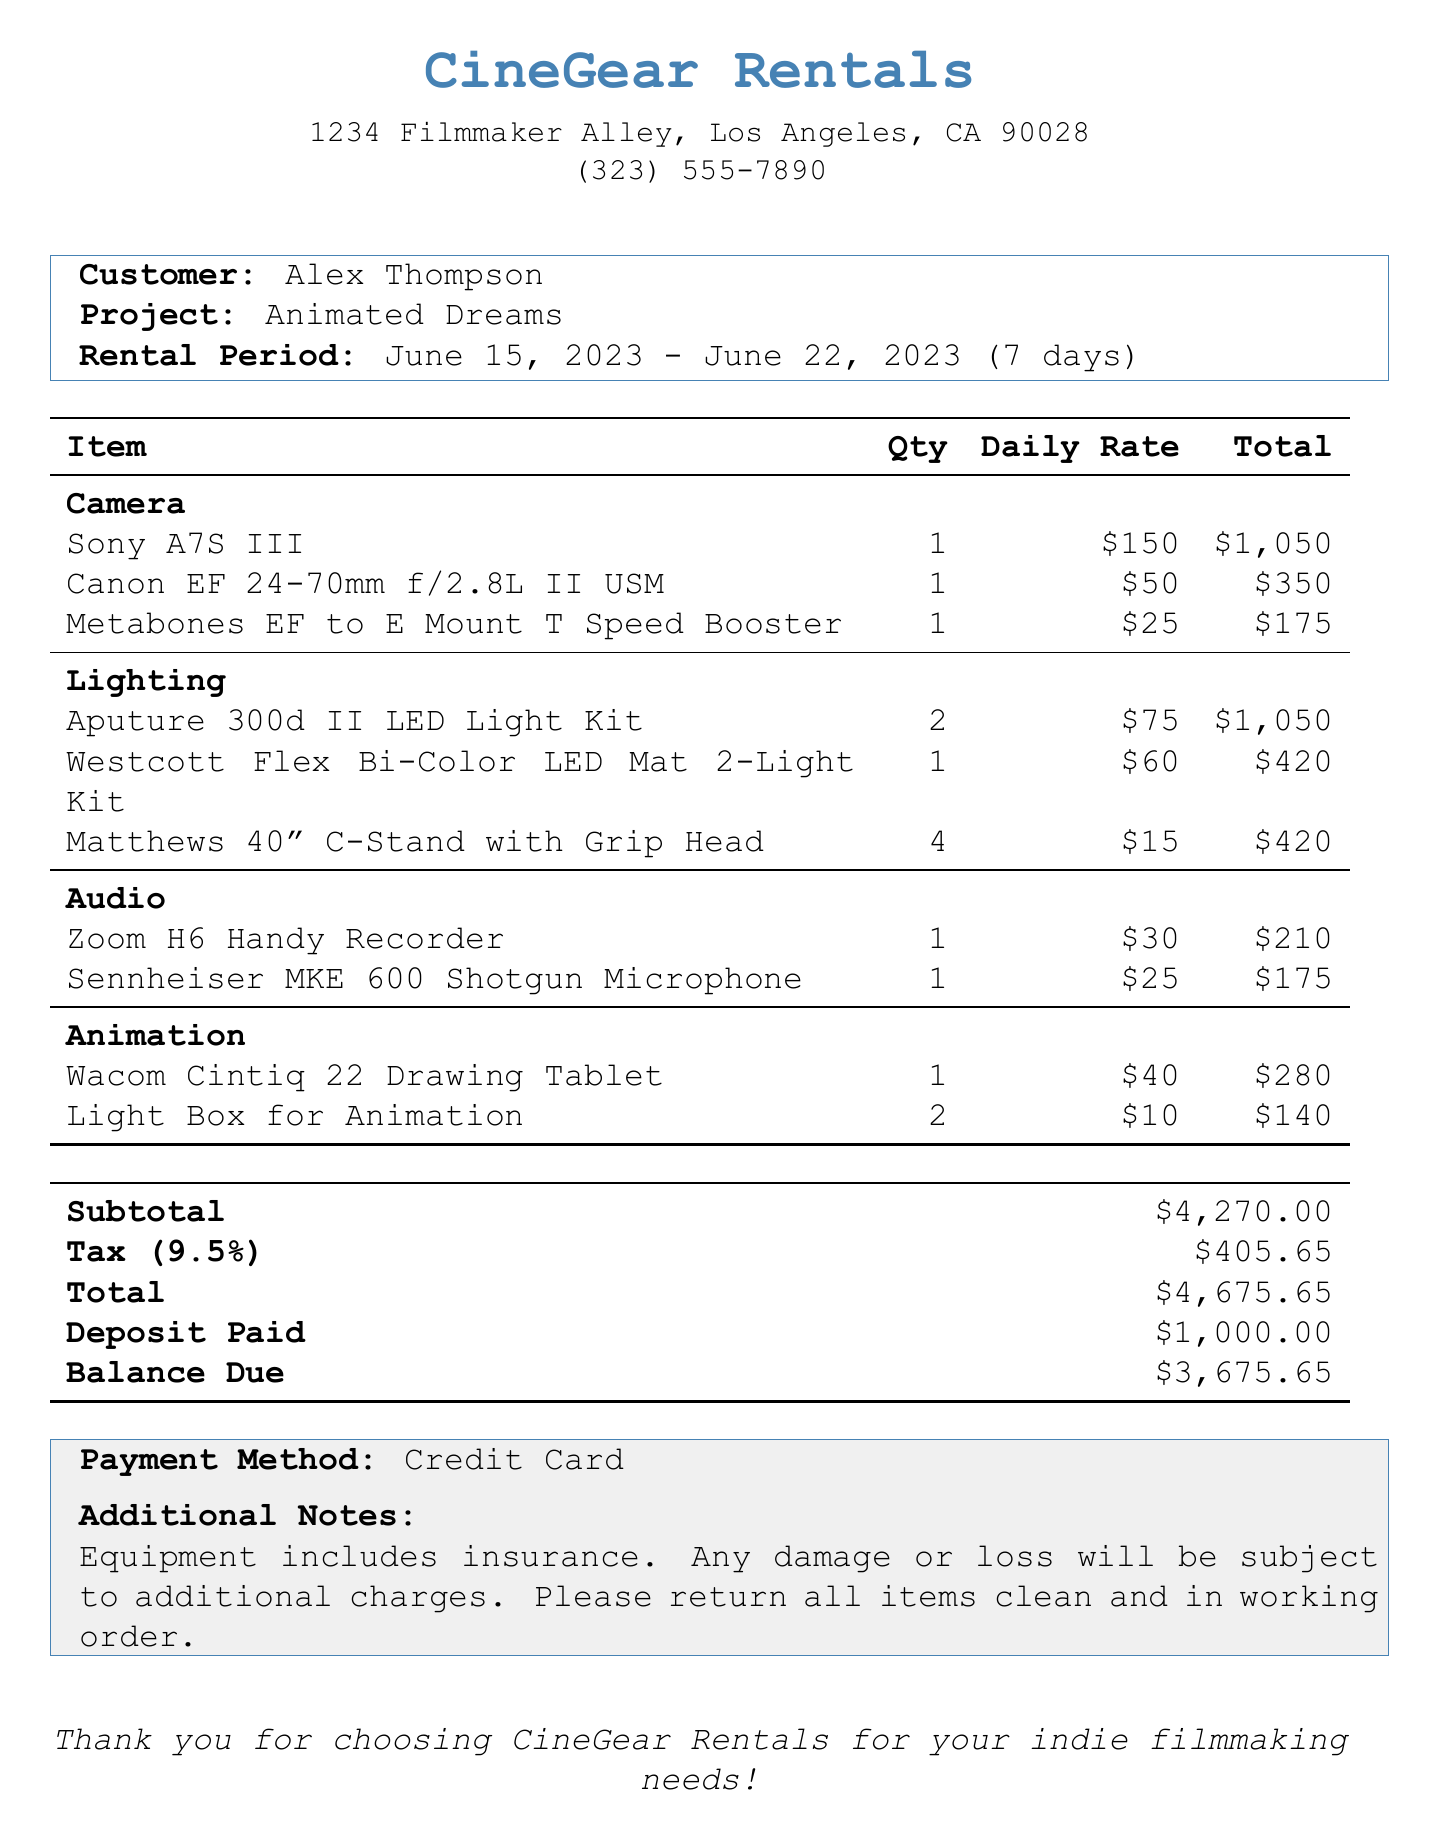what is the company name? The company name is provided at the top of the document.
Answer: CineGear Rentals who is the customer? The customer's name is listed in the document under the customer section.
Answer: Alex Thompson what is the rental period? The rental period is mentioned in the document detailing the start and end dates.
Answer: June 15, 2023 - June 22, 2023 how many total days is the rental period? The total days of rental are explicitly stated in the document.
Answer: 7 what is the subtotal amount? The subtotal amount is clearly labeled in the pricing section of the document.
Answer: $4,270.00 what item had the highest daily rate? To find this, we compare the daily rates of all items in the document.
Answer: Sony A7S III how many Aputure 300d II LED Light Kits were rented? The quantity for each item is listed in the equipment section of the document.
Answer: 2 what is the balance due? The balance due is specified in the financial summary of the document.
Answer: $3,675.65 what type of payment method was used? The payment method is mentioned in the additional notes section of the document.
Answer: Credit Card 